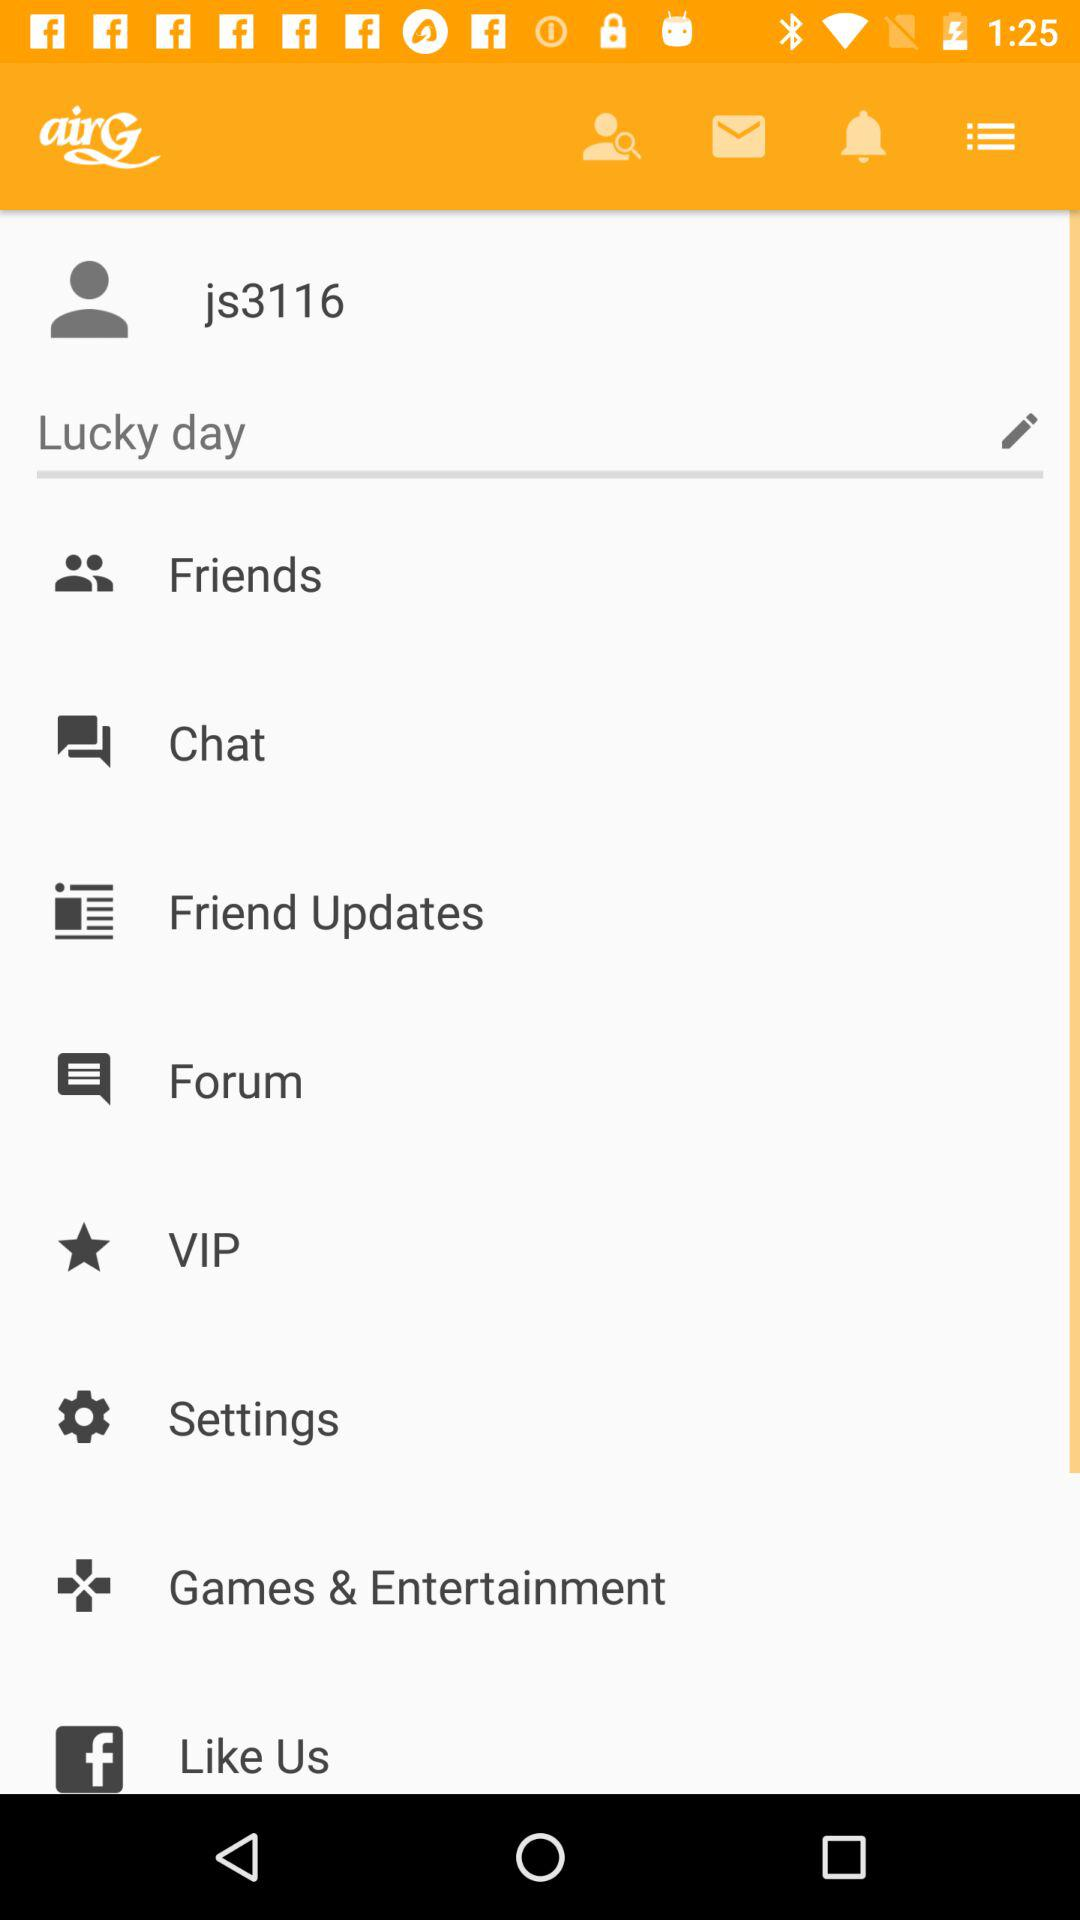What is the user name? The user name is js3116. 